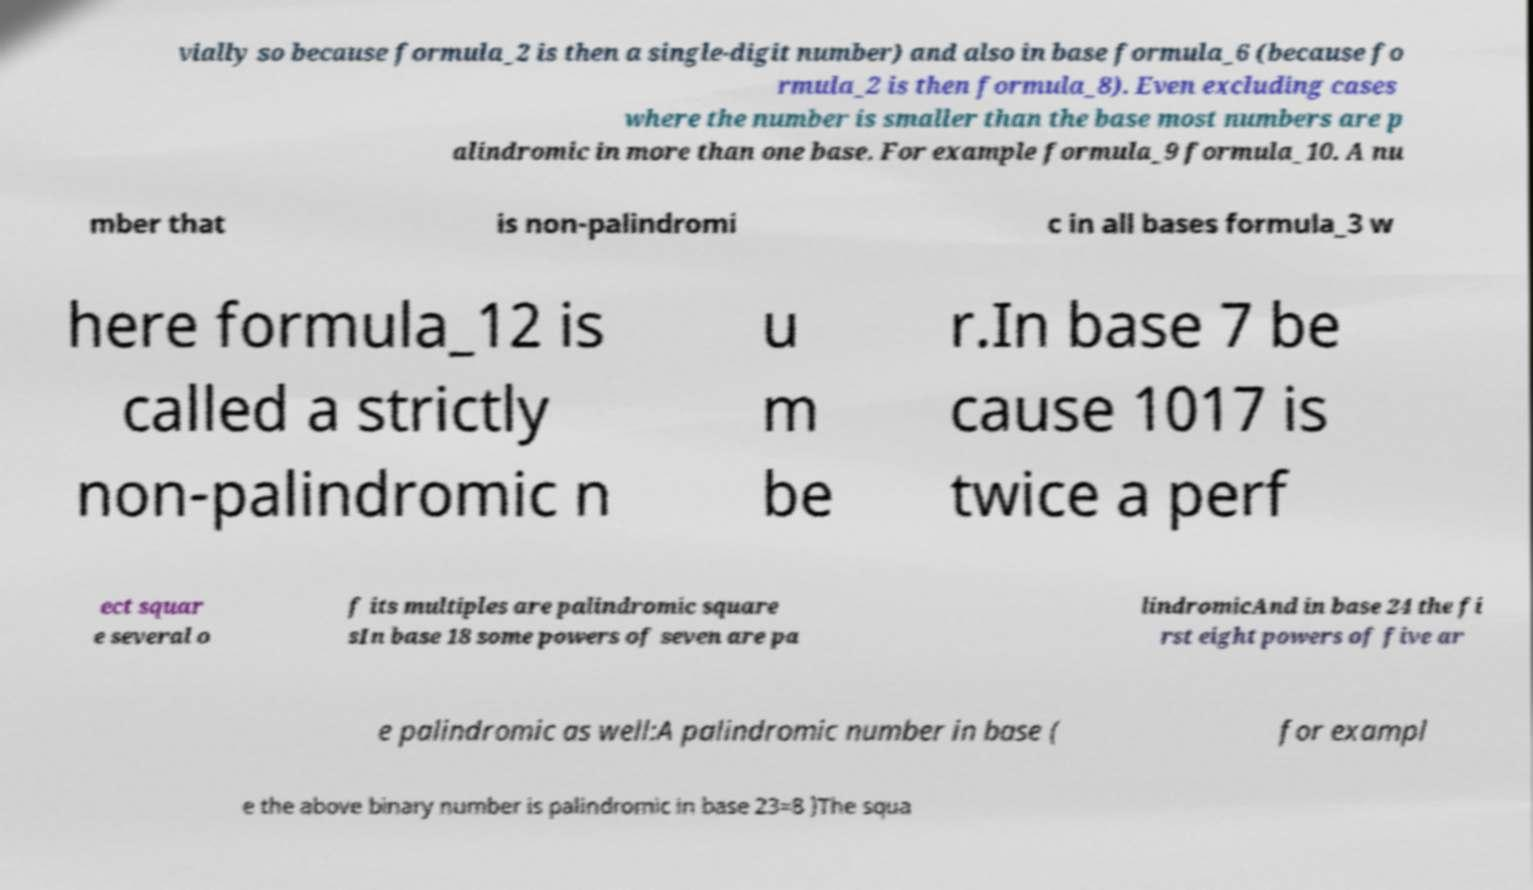Can you read and provide the text displayed in the image?This photo seems to have some interesting text. Can you extract and type it out for me? vially so because formula_2 is then a single-digit number) and also in base formula_6 (because fo rmula_2 is then formula_8). Even excluding cases where the number is smaller than the base most numbers are p alindromic in more than one base. For example formula_9 formula_10. A nu mber that is non-palindromi c in all bases formula_3 w here formula_12 is called a strictly non-palindromic n u m be r.In base 7 be cause 1017 is twice a perf ect squar e several o f its multiples are palindromic square sIn base 18 some powers of seven are pa lindromicAnd in base 24 the fi rst eight powers of five ar e palindromic as well:A palindromic number in base ( for exampl e the above binary number is palindromic in base 23=8 )The squa 